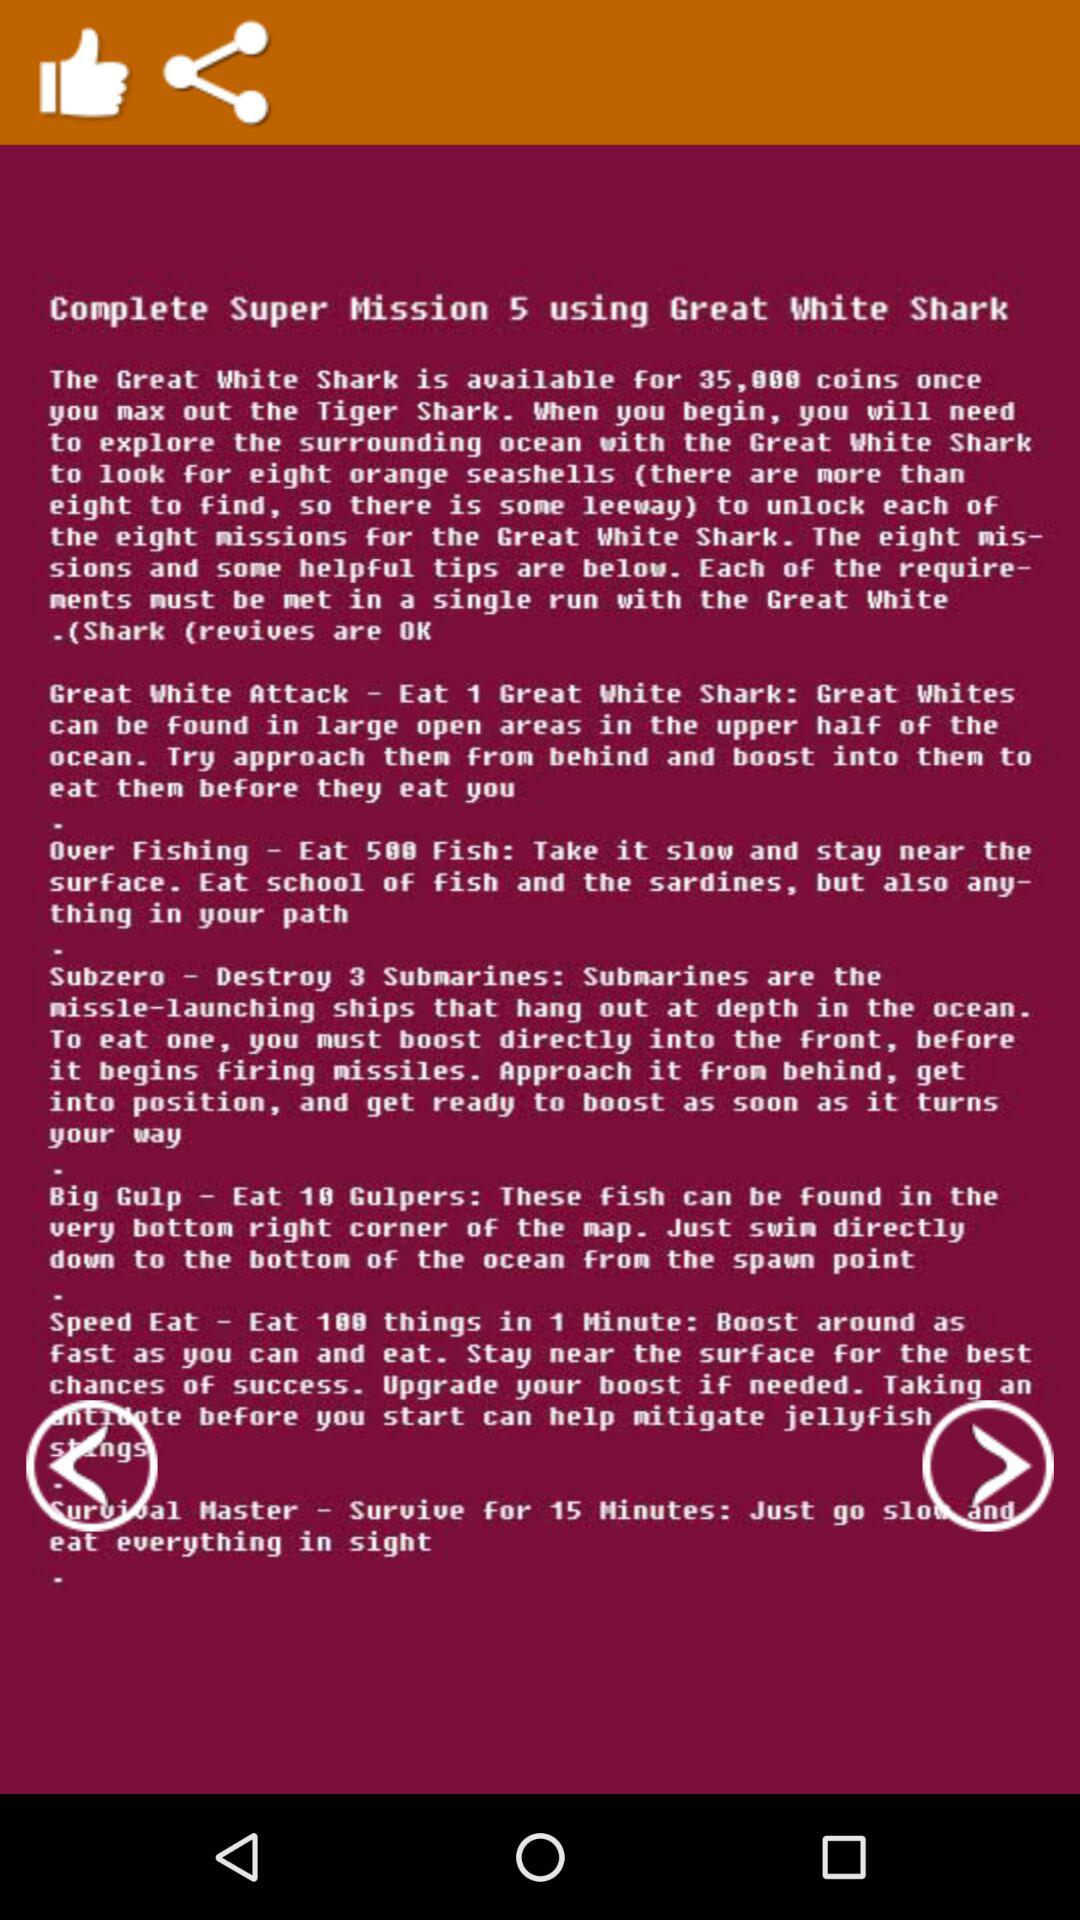How many different types of missions are there?
Answer the question using a single word or phrase. 8 